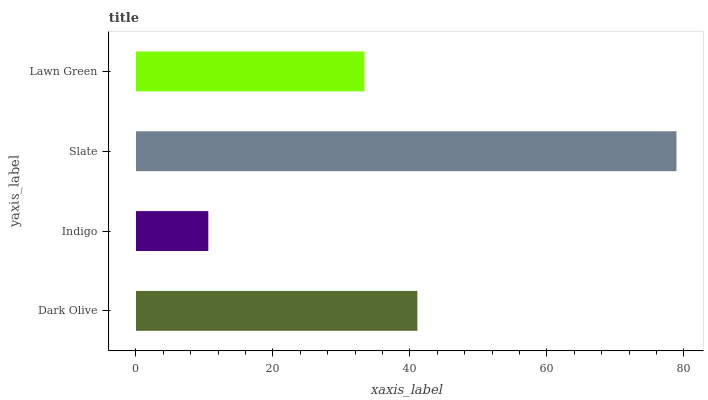Is Indigo the minimum?
Answer yes or no. Yes. Is Slate the maximum?
Answer yes or no. Yes. Is Slate the minimum?
Answer yes or no. No. Is Indigo the maximum?
Answer yes or no. No. Is Slate greater than Indigo?
Answer yes or no. Yes. Is Indigo less than Slate?
Answer yes or no. Yes. Is Indigo greater than Slate?
Answer yes or no. No. Is Slate less than Indigo?
Answer yes or no. No. Is Dark Olive the high median?
Answer yes or no. Yes. Is Lawn Green the low median?
Answer yes or no. Yes. Is Lawn Green the high median?
Answer yes or no. No. Is Indigo the low median?
Answer yes or no. No. 